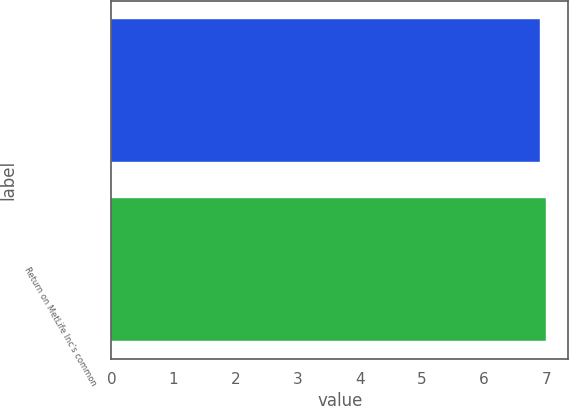<chart> <loc_0><loc_0><loc_500><loc_500><bar_chart><ecel><fcel>Return on MetLife Inc's common<nl><fcel>6.9<fcel>7<nl></chart> 